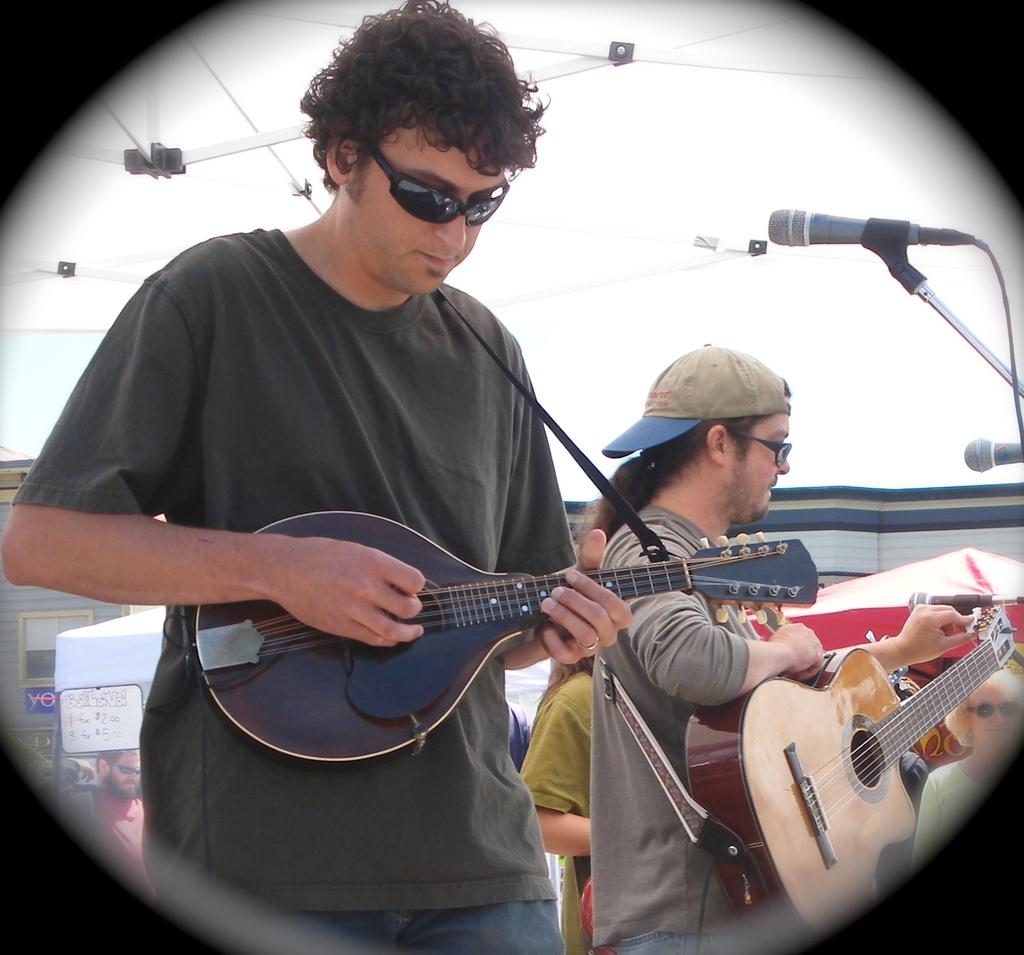What is the main subject of the image? There is a person in the image. What can be observed about the person's appearance? The person is wearing spectacles. What activity is the person engaged in? The person is playing a guitar. What object is beside the person? There is a microphone beside the person. What can be seen in the background of the image? There are tents in the background of the image. How does the tramp contribute to the performance in the image? There is no tramp present in the image; it features a person playing a guitar with a microphone beside them. What direction does the person move in the image? The person is not moving in the image; they are stationary while playing the guitar. 